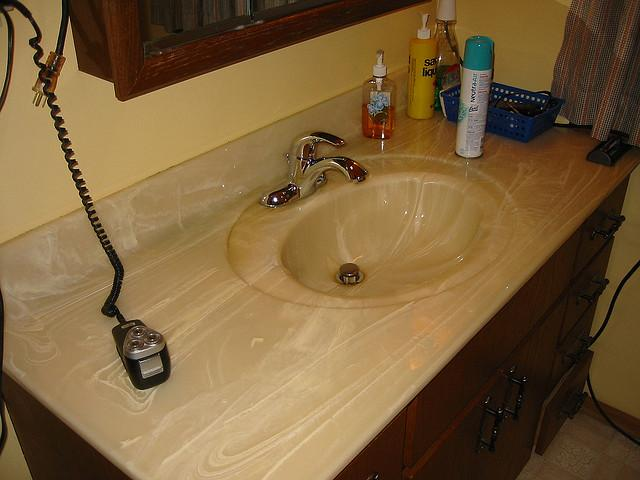What is the corded object called?

Choices:
A) hair iron
B) phone
C) electric razor
D) hair dryer electric razor 